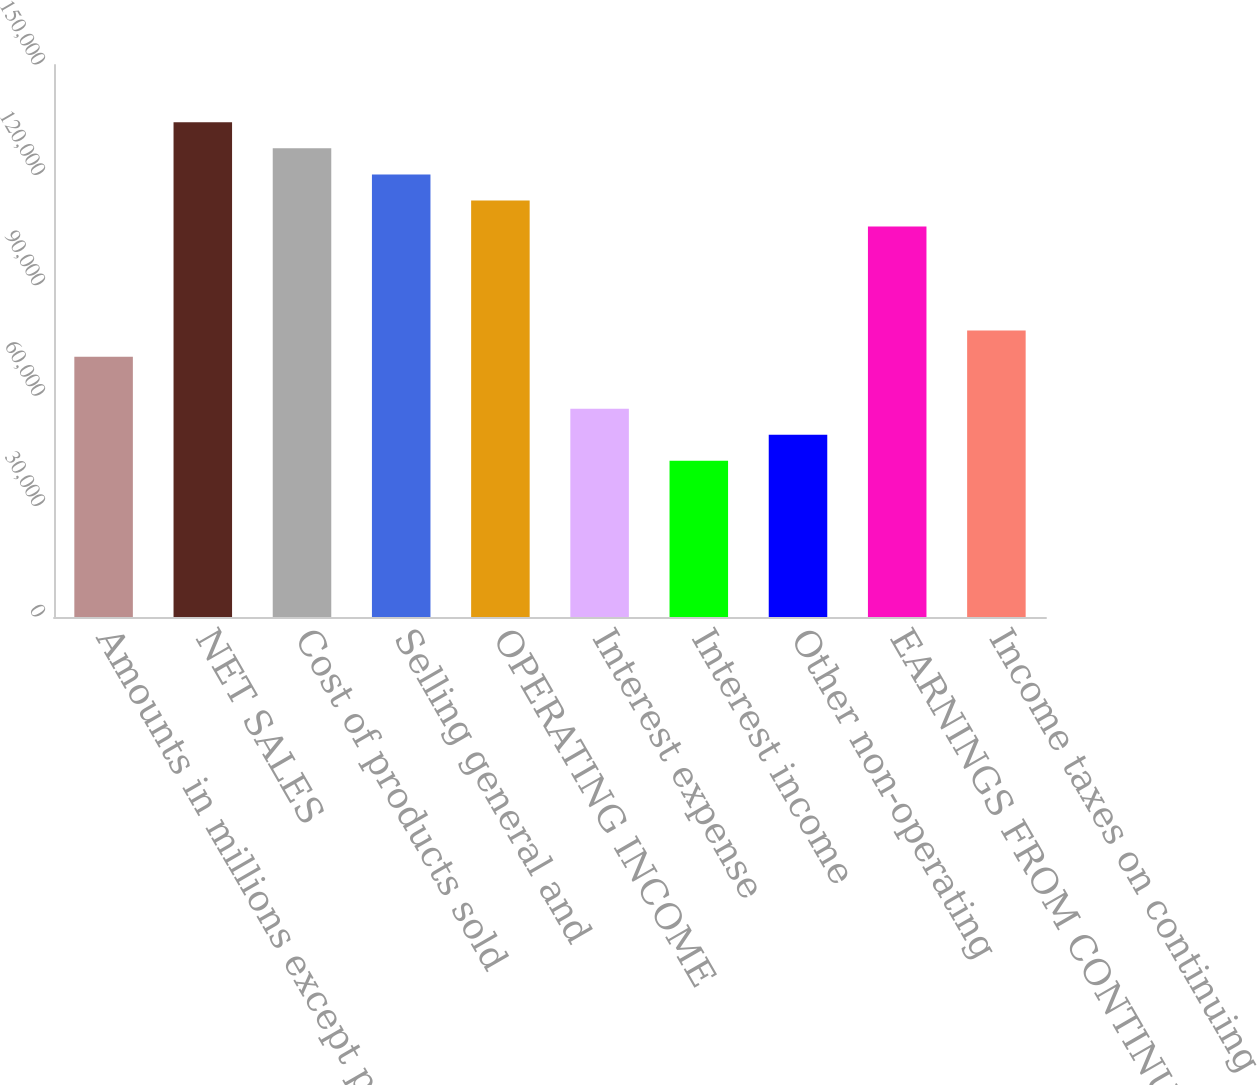Convert chart to OTSL. <chart><loc_0><loc_0><loc_500><loc_500><bar_chart><fcel>Amounts in millions except per<fcel>NET SALES<fcel>Cost of products sold<fcel>Selling general and<fcel>OPERATING INCOME<fcel>Interest expense<fcel>Interest income<fcel>Other non-operating<fcel>EARNINGS FROM CONTINUING<fcel>Income taxes on continuing<nl><fcel>70749<fcel>134423<fcel>127348<fcel>120273<fcel>113198<fcel>56599.3<fcel>42449.6<fcel>49524.4<fcel>106123<fcel>77823.9<nl></chart> 